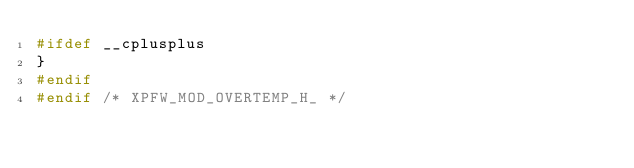Convert code to text. <code><loc_0><loc_0><loc_500><loc_500><_C_>#ifdef __cplusplus
}
#endif
#endif /* XPFW_MOD_OVERTEMP_H_ */
</code> 